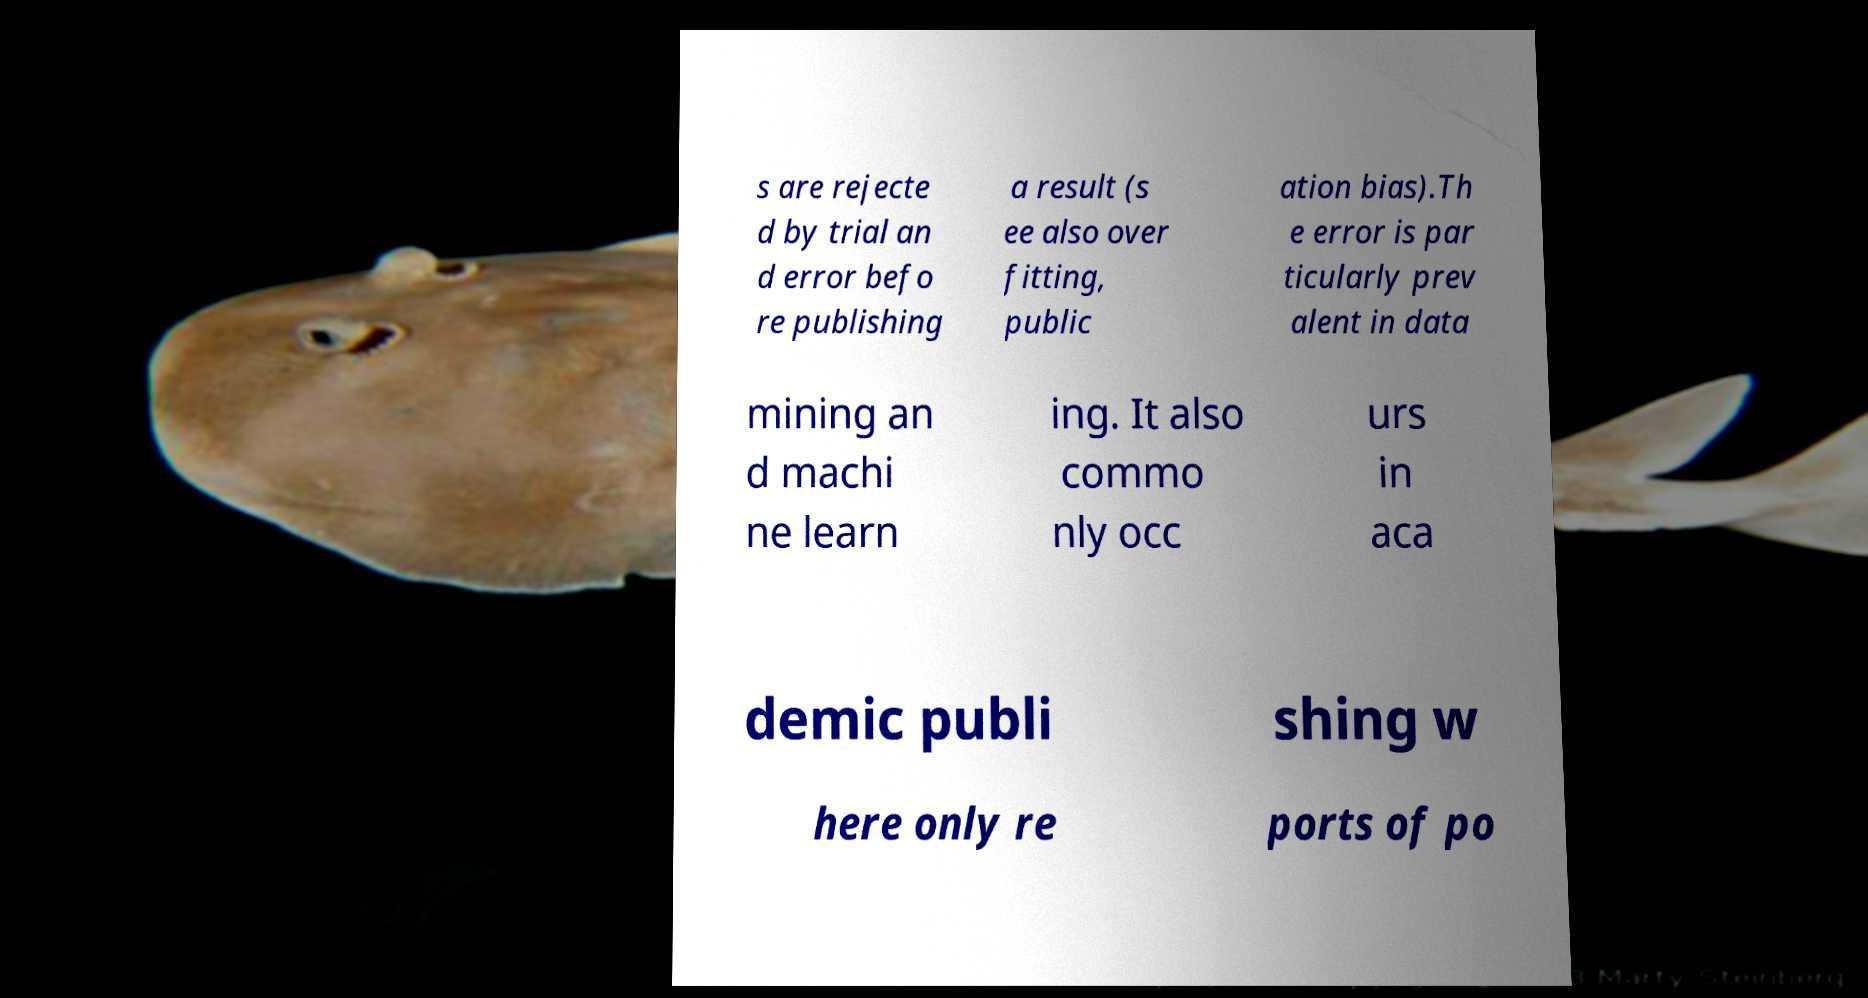Could you extract and type out the text from this image? s are rejecte d by trial an d error befo re publishing a result (s ee also over fitting, public ation bias).Th e error is par ticularly prev alent in data mining an d machi ne learn ing. It also commo nly occ urs in aca demic publi shing w here only re ports of po 